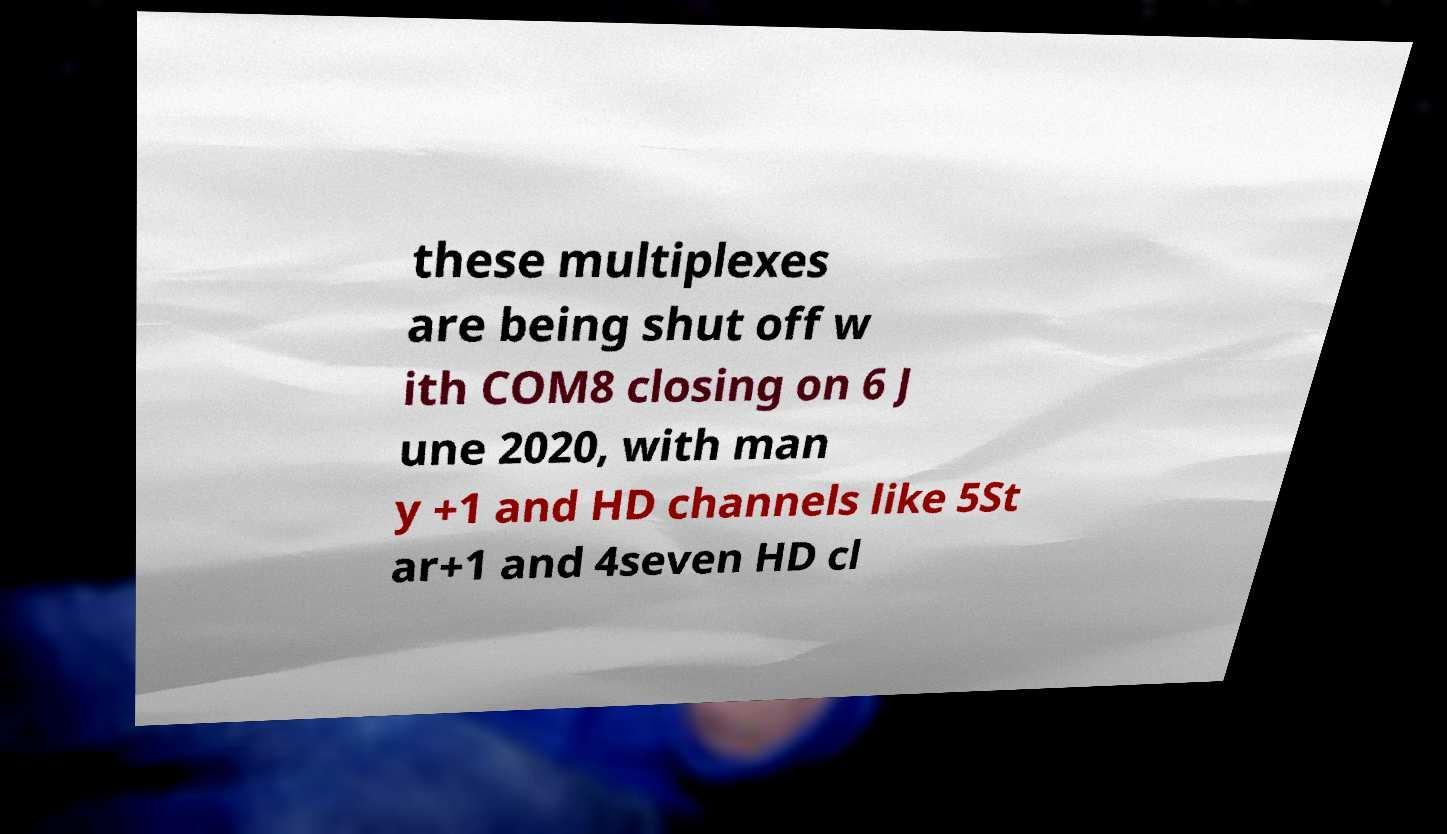Can you accurately transcribe the text from the provided image for me? these multiplexes are being shut off w ith COM8 closing on 6 J une 2020, with man y +1 and HD channels like 5St ar+1 and 4seven HD cl 